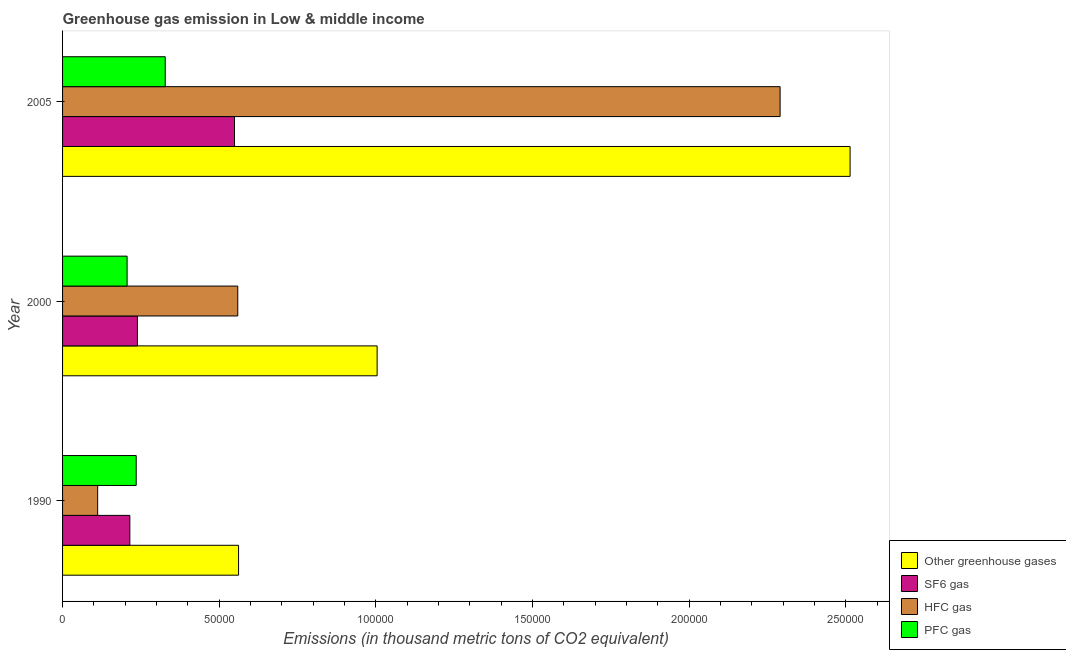Are the number of bars per tick equal to the number of legend labels?
Your answer should be very brief. Yes. Are the number of bars on each tick of the Y-axis equal?
Your response must be concise. Yes. How many bars are there on the 1st tick from the top?
Your answer should be compact. 4. What is the emission of greenhouse gases in 1990?
Provide a succinct answer. 5.62e+04. Across all years, what is the maximum emission of hfc gas?
Offer a very short reply. 2.29e+05. Across all years, what is the minimum emission of hfc gas?
Provide a short and direct response. 1.12e+04. In which year was the emission of sf6 gas maximum?
Make the answer very short. 2005. What is the total emission of sf6 gas in the graph?
Your answer should be very brief. 1.00e+05. What is the difference between the emission of pfc gas in 2000 and that in 2005?
Your answer should be very brief. -1.22e+04. What is the difference between the emission of sf6 gas in 2000 and the emission of greenhouse gases in 2005?
Provide a succinct answer. -2.27e+05. What is the average emission of sf6 gas per year?
Ensure brevity in your answer.  3.34e+04. In the year 1990, what is the difference between the emission of sf6 gas and emission of greenhouse gases?
Keep it short and to the point. -3.47e+04. What is the ratio of the emission of greenhouse gases in 1990 to that in 2000?
Keep it short and to the point. 0.56. Is the difference between the emission of sf6 gas in 1990 and 2000 greater than the difference between the emission of hfc gas in 1990 and 2000?
Offer a terse response. Yes. What is the difference between the highest and the second highest emission of pfc gas?
Offer a very short reply. 9268.08. What is the difference between the highest and the lowest emission of pfc gas?
Keep it short and to the point. 1.22e+04. In how many years, is the emission of pfc gas greater than the average emission of pfc gas taken over all years?
Offer a very short reply. 1. Is the sum of the emission of pfc gas in 1990 and 2005 greater than the maximum emission of hfc gas across all years?
Make the answer very short. No. What does the 4th bar from the top in 2000 represents?
Your answer should be very brief. Other greenhouse gases. What does the 1st bar from the bottom in 2005 represents?
Make the answer very short. Other greenhouse gases. Are all the bars in the graph horizontal?
Your answer should be compact. Yes. How many years are there in the graph?
Your response must be concise. 3. What is the difference between two consecutive major ticks on the X-axis?
Your answer should be compact. 5.00e+04. Are the values on the major ticks of X-axis written in scientific E-notation?
Make the answer very short. No. What is the title of the graph?
Keep it short and to the point. Greenhouse gas emission in Low & middle income. What is the label or title of the X-axis?
Offer a terse response. Emissions (in thousand metric tons of CO2 equivalent). What is the label or title of the Y-axis?
Your response must be concise. Year. What is the Emissions (in thousand metric tons of CO2 equivalent) of Other greenhouse gases in 1990?
Provide a short and direct response. 5.62e+04. What is the Emissions (in thousand metric tons of CO2 equivalent) in SF6 gas in 1990?
Offer a very short reply. 2.15e+04. What is the Emissions (in thousand metric tons of CO2 equivalent) in HFC gas in 1990?
Your answer should be compact. 1.12e+04. What is the Emissions (in thousand metric tons of CO2 equivalent) of PFC gas in 1990?
Your response must be concise. 2.35e+04. What is the Emissions (in thousand metric tons of CO2 equivalent) in Other greenhouse gases in 2000?
Provide a succinct answer. 1.00e+05. What is the Emissions (in thousand metric tons of CO2 equivalent) in SF6 gas in 2000?
Offer a very short reply. 2.39e+04. What is the Emissions (in thousand metric tons of CO2 equivalent) in HFC gas in 2000?
Your answer should be very brief. 5.59e+04. What is the Emissions (in thousand metric tons of CO2 equivalent) of PFC gas in 2000?
Give a very brief answer. 2.06e+04. What is the Emissions (in thousand metric tons of CO2 equivalent) in Other greenhouse gases in 2005?
Your response must be concise. 2.51e+05. What is the Emissions (in thousand metric tons of CO2 equivalent) of SF6 gas in 2005?
Ensure brevity in your answer.  5.49e+04. What is the Emissions (in thousand metric tons of CO2 equivalent) in HFC gas in 2005?
Ensure brevity in your answer.  2.29e+05. What is the Emissions (in thousand metric tons of CO2 equivalent) in PFC gas in 2005?
Offer a very short reply. 3.28e+04. Across all years, what is the maximum Emissions (in thousand metric tons of CO2 equivalent) of Other greenhouse gases?
Provide a succinct answer. 2.51e+05. Across all years, what is the maximum Emissions (in thousand metric tons of CO2 equivalent) of SF6 gas?
Give a very brief answer. 5.49e+04. Across all years, what is the maximum Emissions (in thousand metric tons of CO2 equivalent) of HFC gas?
Offer a very short reply. 2.29e+05. Across all years, what is the maximum Emissions (in thousand metric tons of CO2 equivalent) of PFC gas?
Provide a short and direct response. 3.28e+04. Across all years, what is the minimum Emissions (in thousand metric tons of CO2 equivalent) in Other greenhouse gases?
Ensure brevity in your answer.  5.62e+04. Across all years, what is the minimum Emissions (in thousand metric tons of CO2 equivalent) of SF6 gas?
Keep it short and to the point. 2.15e+04. Across all years, what is the minimum Emissions (in thousand metric tons of CO2 equivalent) of HFC gas?
Offer a very short reply. 1.12e+04. Across all years, what is the minimum Emissions (in thousand metric tons of CO2 equivalent) in PFC gas?
Provide a short and direct response. 2.06e+04. What is the total Emissions (in thousand metric tons of CO2 equivalent) in Other greenhouse gases in the graph?
Give a very brief answer. 4.08e+05. What is the total Emissions (in thousand metric tons of CO2 equivalent) of SF6 gas in the graph?
Make the answer very short. 1.00e+05. What is the total Emissions (in thousand metric tons of CO2 equivalent) in HFC gas in the graph?
Your response must be concise. 2.96e+05. What is the total Emissions (in thousand metric tons of CO2 equivalent) of PFC gas in the graph?
Your answer should be compact. 7.69e+04. What is the difference between the Emissions (in thousand metric tons of CO2 equivalent) of Other greenhouse gases in 1990 and that in 2000?
Provide a succinct answer. -4.42e+04. What is the difference between the Emissions (in thousand metric tons of CO2 equivalent) of SF6 gas in 1990 and that in 2000?
Provide a short and direct response. -2413.4. What is the difference between the Emissions (in thousand metric tons of CO2 equivalent) of HFC gas in 1990 and that in 2000?
Your answer should be very brief. -4.47e+04. What is the difference between the Emissions (in thousand metric tons of CO2 equivalent) in PFC gas in 1990 and that in 2000?
Keep it short and to the point. 2906.6. What is the difference between the Emissions (in thousand metric tons of CO2 equivalent) in Other greenhouse gases in 1990 and that in 2005?
Keep it short and to the point. -1.95e+05. What is the difference between the Emissions (in thousand metric tons of CO2 equivalent) of SF6 gas in 1990 and that in 2005?
Your answer should be very brief. -3.34e+04. What is the difference between the Emissions (in thousand metric tons of CO2 equivalent) in HFC gas in 1990 and that in 2005?
Make the answer very short. -2.18e+05. What is the difference between the Emissions (in thousand metric tons of CO2 equivalent) in PFC gas in 1990 and that in 2005?
Your response must be concise. -9268.08. What is the difference between the Emissions (in thousand metric tons of CO2 equivalent) in Other greenhouse gases in 2000 and that in 2005?
Offer a terse response. -1.51e+05. What is the difference between the Emissions (in thousand metric tons of CO2 equivalent) in SF6 gas in 2000 and that in 2005?
Give a very brief answer. -3.10e+04. What is the difference between the Emissions (in thousand metric tons of CO2 equivalent) in HFC gas in 2000 and that in 2005?
Provide a short and direct response. -1.73e+05. What is the difference between the Emissions (in thousand metric tons of CO2 equivalent) of PFC gas in 2000 and that in 2005?
Make the answer very short. -1.22e+04. What is the difference between the Emissions (in thousand metric tons of CO2 equivalent) in Other greenhouse gases in 1990 and the Emissions (in thousand metric tons of CO2 equivalent) in SF6 gas in 2000?
Provide a short and direct response. 3.23e+04. What is the difference between the Emissions (in thousand metric tons of CO2 equivalent) in Other greenhouse gases in 1990 and the Emissions (in thousand metric tons of CO2 equivalent) in HFC gas in 2000?
Provide a short and direct response. 253.4. What is the difference between the Emissions (in thousand metric tons of CO2 equivalent) in Other greenhouse gases in 1990 and the Emissions (in thousand metric tons of CO2 equivalent) in PFC gas in 2000?
Your answer should be compact. 3.56e+04. What is the difference between the Emissions (in thousand metric tons of CO2 equivalent) of SF6 gas in 1990 and the Emissions (in thousand metric tons of CO2 equivalent) of HFC gas in 2000?
Your response must be concise. -3.44e+04. What is the difference between the Emissions (in thousand metric tons of CO2 equivalent) of SF6 gas in 1990 and the Emissions (in thousand metric tons of CO2 equivalent) of PFC gas in 2000?
Offer a terse response. 878. What is the difference between the Emissions (in thousand metric tons of CO2 equivalent) of HFC gas in 1990 and the Emissions (in thousand metric tons of CO2 equivalent) of PFC gas in 2000?
Provide a succinct answer. -9395.9. What is the difference between the Emissions (in thousand metric tons of CO2 equivalent) in Other greenhouse gases in 1990 and the Emissions (in thousand metric tons of CO2 equivalent) in SF6 gas in 2005?
Give a very brief answer. 1290.31. What is the difference between the Emissions (in thousand metric tons of CO2 equivalent) in Other greenhouse gases in 1990 and the Emissions (in thousand metric tons of CO2 equivalent) in HFC gas in 2005?
Provide a succinct answer. -1.73e+05. What is the difference between the Emissions (in thousand metric tons of CO2 equivalent) in Other greenhouse gases in 1990 and the Emissions (in thousand metric tons of CO2 equivalent) in PFC gas in 2005?
Give a very brief answer. 2.34e+04. What is the difference between the Emissions (in thousand metric tons of CO2 equivalent) of SF6 gas in 1990 and the Emissions (in thousand metric tons of CO2 equivalent) of HFC gas in 2005?
Keep it short and to the point. -2.08e+05. What is the difference between the Emissions (in thousand metric tons of CO2 equivalent) of SF6 gas in 1990 and the Emissions (in thousand metric tons of CO2 equivalent) of PFC gas in 2005?
Ensure brevity in your answer.  -1.13e+04. What is the difference between the Emissions (in thousand metric tons of CO2 equivalent) in HFC gas in 1990 and the Emissions (in thousand metric tons of CO2 equivalent) in PFC gas in 2005?
Ensure brevity in your answer.  -2.16e+04. What is the difference between the Emissions (in thousand metric tons of CO2 equivalent) in Other greenhouse gases in 2000 and the Emissions (in thousand metric tons of CO2 equivalent) in SF6 gas in 2005?
Your answer should be very brief. 4.55e+04. What is the difference between the Emissions (in thousand metric tons of CO2 equivalent) of Other greenhouse gases in 2000 and the Emissions (in thousand metric tons of CO2 equivalent) of HFC gas in 2005?
Your answer should be compact. -1.29e+05. What is the difference between the Emissions (in thousand metric tons of CO2 equivalent) in Other greenhouse gases in 2000 and the Emissions (in thousand metric tons of CO2 equivalent) in PFC gas in 2005?
Make the answer very short. 6.76e+04. What is the difference between the Emissions (in thousand metric tons of CO2 equivalent) in SF6 gas in 2000 and the Emissions (in thousand metric tons of CO2 equivalent) in HFC gas in 2005?
Offer a terse response. -2.05e+05. What is the difference between the Emissions (in thousand metric tons of CO2 equivalent) in SF6 gas in 2000 and the Emissions (in thousand metric tons of CO2 equivalent) in PFC gas in 2005?
Your answer should be compact. -8883.28. What is the difference between the Emissions (in thousand metric tons of CO2 equivalent) in HFC gas in 2000 and the Emissions (in thousand metric tons of CO2 equivalent) in PFC gas in 2005?
Your answer should be compact. 2.32e+04. What is the average Emissions (in thousand metric tons of CO2 equivalent) in Other greenhouse gases per year?
Your answer should be very brief. 1.36e+05. What is the average Emissions (in thousand metric tons of CO2 equivalent) of SF6 gas per year?
Make the answer very short. 3.34e+04. What is the average Emissions (in thousand metric tons of CO2 equivalent) of HFC gas per year?
Your response must be concise. 9.87e+04. What is the average Emissions (in thousand metric tons of CO2 equivalent) of PFC gas per year?
Keep it short and to the point. 2.56e+04. In the year 1990, what is the difference between the Emissions (in thousand metric tons of CO2 equivalent) in Other greenhouse gases and Emissions (in thousand metric tons of CO2 equivalent) in SF6 gas?
Keep it short and to the point. 3.47e+04. In the year 1990, what is the difference between the Emissions (in thousand metric tons of CO2 equivalent) in Other greenhouse gases and Emissions (in thousand metric tons of CO2 equivalent) in HFC gas?
Ensure brevity in your answer.  4.50e+04. In the year 1990, what is the difference between the Emissions (in thousand metric tons of CO2 equivalent) in Other greenhouse gases and Emissions (in thousand metric tons of CO2 equivalent) in PFC gas?
Give a very brief answer. 3.27e+04. In the year 1990, what is the difference between the Emissions (in thousand metric tons of CO2 equivalent) in SF6 gas and Emissions (in thousand metric tons of CO2 equivalent) in HFC gas?
Your response must be concise. 1.03e+04. In the year 1990, what is the difference between the Emissions (in thousand metric tons of CO2 equivalent) of SF6 gas and Emissions (in thousand metric tons of CO2 equivalent) of PFC gas?
Make the answer very short. -2028.6. In the year 1990, what is the difference between the Emissions (in thousand metric tons of CO2 equivalent) in HFC gas and Emissions (in thousand metric tons of CO2 equivalent) in PFC gas?
Your response must be concise. -1.23e+04. In the year 2000, what is the difference between the Emissions (in thousand metric tons of CO2 equivalent) in Other greenhouse gases and Emissions (in thousand metric tons of CO2 equivalent) in SF6 gas?
Your answer should be very brief. 7.65e+04. In the year 2000, what is the difference between the Emissions (in thousand metric tons of CO2 equivalent) of Other greenhouse gases and Emissions (in thousand metric tons of CO2 equivalent) of HFC gas?
Your answer should be compact. 4.45e+04. In the year 2000, what is the difference between the Emissions (in thousand metric tons of CO2 equivalent) of Other greenhouse gases and Emissions (in thousand metric tons of CO2 equivalent) of PFC gas?
Make the answer very short. 7.98e+04. In the year 2000, what is the difference between the Emissions (in thousand metric tons of CO2 equivalent) in SF6 gas and Emissions (in thousand metric tons of CO2 equivalent) in HFC gas?
Your answer should be very brief. -3.20e+04. In the year 2000, what is the difference between the Emissions (in thousand metric tons of CO2 equivalent) in SF6 gas and Emissions (in thousand metric tons of CO2 equivalent) in PFC gas?
Make the answer very short. 3291.4. In the year 2000, what is the difference between the Emissions (in thousand metric tons of CO2 equivalent) in HFC gas and Emissions (in thousand metric tons of CO2 equivalent) in PFC gas?
Provide a succinct answer. 3.53e+04. In the year 2005, what is the difference between the Emissions (in thousand metric tons of CO2 equivalent) of Other greenhouse gases and Emissions (in thousand metric tons of CO2 equivalent) of SF6 gas?
Keep it short and to the point. 1.96e+05. In the year 2005, what is the difference between the Emissions (in thousand metric tons of CO2 equivalent) in Other greenhouse gases and Emissions (in thousand metric tons of CO2 equivalent) in HFC gas?
Your answer should be compact. 2.23e+04. In the year 2005, what is the difference between the Emissions (in thousand metric tons of CO2 equivalent) of Other greenhouse gases and Emissions (in thousand metric tons of CO2 equivalent) of PFC gas?
Make the answer very short. 2.19e+05. In the year 2005, what is the difference between the Emissions (in thousand metric tons of CO2 equivalent) of SF6 gas and Emissions (in thousand metric tons of CO2 equivalent) of HFC gas?
Ensure brevity in your answer.  -1.74e+05. In the year 2005, what is the difference between the Emissions (in thousand metric tons of CO2 equivalent) of SF6 gas and Emissions (in thousand metric tons of CO2 equivalent) of PFC gas?
Give a very brief answer. 2.21e+04. In the year 2005, what is the difference between the Emissions (in thousand metric tons of CO2 equivalent) of HFC gas and Emissions (in thousand metric tons of CO2 equivalent) of PFC gas?
Provide a short and direct response. 1.96e+05. What is the ratio of the Emissions (in thousand metric tons of CO2 equivalent) in Other greenhouse gases in 1990 to that in 2000?
Ensure brevity in your answer.  0.56. What is the ratio of the Emissions (in thousand metric tons of CO2 equivalent) of SF6 gas in 1990 to that in 2000?
Offer a terse response. 0.9. What is the ratio of the Emissions (in thousand metric tons of CO2 equivalent) in HFC gas in 1990 to that in 2000?
Provide a succinct answer. 0.2. What is the ratio of the Emissions (in thousand metric tons of CO2 equivalent) of PFC gas in 1990 to that in 2000?
Provide a succinct answer. 1.14. What is the ratio of the Emissions (in thousand metric tons of CO2 equivalent) of Other greenhouse gases in 1990 to that in 2005?
Your answer should be compact. 0.22. What is the ratio of the Emissions (in thousand metric tons of CO2 equivalent) in SF6 gas in 1990 to that in 2005?
Your answer should be very brief. 0.39. What is the ratio of the Emissions (in thousand metric tons of CO2 equivalent) of HFC gas in 1990 to that in 2005?
Your answer should be compact. 0.05. What is the ratio of the Emissions (in thousand metric tons of CO2 equivalent) of PFC gas in 1990 to that in 2005?
Your answer should be very brief. 0.72. What is the ratio of the Emissions (in thousand metric tons of CO2 equivalent) in Other greenhouse gases in 2000 to that in 2005?
Give a very brief answer. 0.4. What is the ratio of the Emissions (in thousand metric tons of CO2 equivalent) of SF6 gas in 2000 to that in 2005?
Offer a terse response. 0.44. What is the ratio of the Emissions (in thousand metric tons of CO2 equivalent) of HFC gas in 2000 to that in 2005?
Provide a succinct answer. 0.24. What is the ratio of the Emissions (in thousand metric tons of CO2 equivalent) in PFC gas in 2000 to that in 2005?
Offer a very short reply. 0.63. What is the difference between the highest and the second highest Emissions (in thousand metric tons of CO2 equivalent) in Other greenhouse gases?
Your response must be concise. 1.51e+05. What is the difference between the highest and the second highest Emissions (in thousand metric tons of CO2 equivalent) of SF6 gas?
Ensure brevity in your answer.  3.10e+04. What is the difference between the highest and the second highest Emissions (in thousand metric tons of CO2 equivalent) in HFC gas?
Give a very brief answer. 1.73e+05. What is the difference between the highest and the second highest Emissions (in thousand metric tons of CO2 equivalent) in PFC gas?
Keep it short and to the point. 9268.08. What is the difference between the highest and the lowest Emissions (in thousand metric tons of CO2 equivalent) of Other greenhouse gases?
Offer a very short reply. 1.95e+05. What is the difference between the highest and the lowest Emissions (in thousand metric tons of CO2 equivalent) of SF6 gas?
Provide a short and direct response. 3.34e+04. What is the difference between the highest and the lowest Emissions (in thousand metric tons of CO2 equivalent) of HFC gas?
Keep it short and to the point. 2.18e+05. What is the difference between the highest and the lowest Emissions (in thousand metric tons of CO2 equivalent) in PFC gas?
Provide a succinct answer. 1.22e+04. 